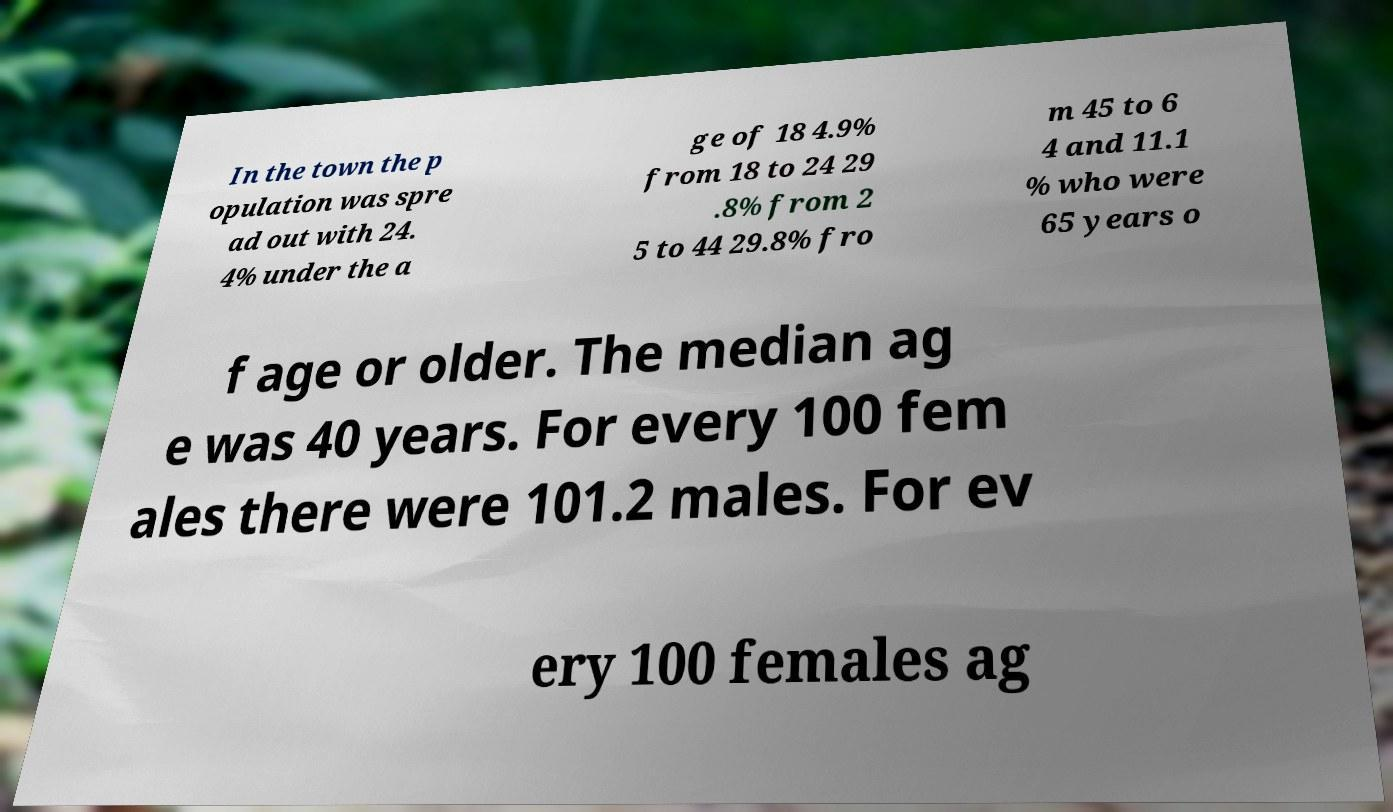Can you read and provide the text displayed in the image?This photo seems to have some interesting text. Can you extract and type it out for me? In the town the p opulation was spre ad out with 24. 4% under the a ge of 18 4.9% from 18 to 24 29 .8% from 2 5 to 44 29.8% fro m 45 to 6 4 and 11.1 % who were 65 years o f age or older. The median ag e was 40 years. For every 100 fem ales there were 101.2 males. For ev ery 100 females ag 